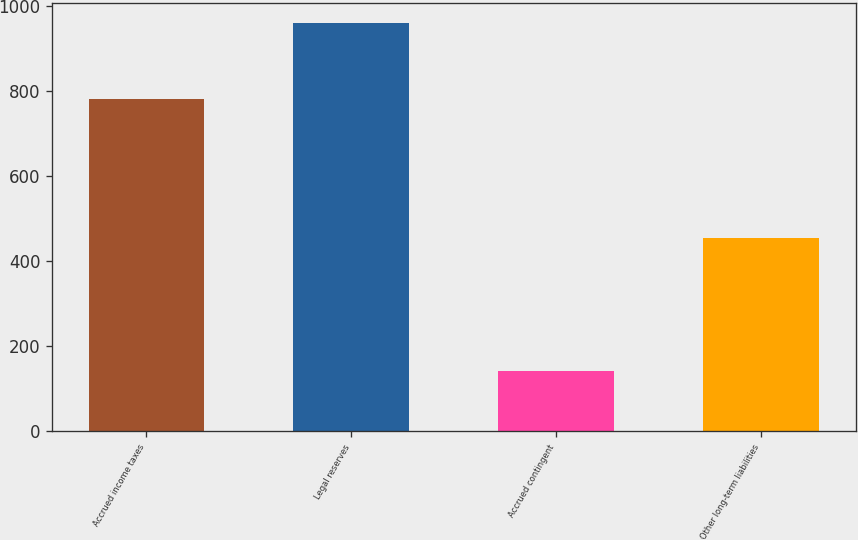<chart> <loc_0><loc_0><loc_500><loc_500><bar_chart><fcel>Accrued income taxes<fcel>Legal reserves<fcel>Accrued contingent<fcel>Other long-term liabilities<nl><fcel>781<fcel>961<fcel>141<fcel>455<nl></chart> 